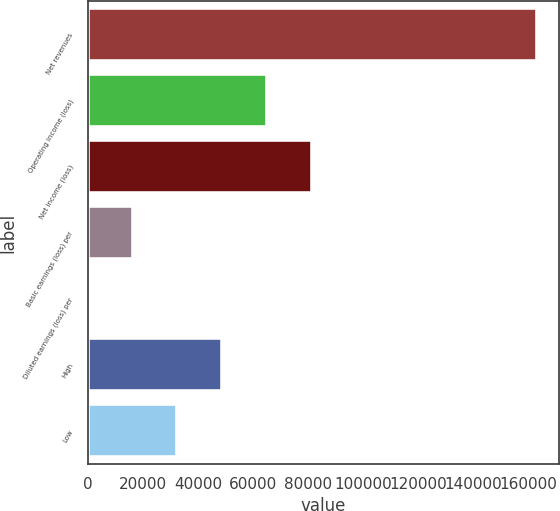Convert chart. <chart><loc_0><loc_0><loc_500><loc_500><bar_chart><fcel>Net revenues<fcel>Operating income (loss)<fcel>Net income (loss)<fcel>Basic earnings (loss) per<fcel>Diluted earnings (loss) per<fcel>High<fcel>Low<nl><fcel>162897<fcel>65158.8<fcel>81448.5<fcel>16289.7<fcel>0.04<fcel>48869.1<fcel>32579.4<nl></chart> 